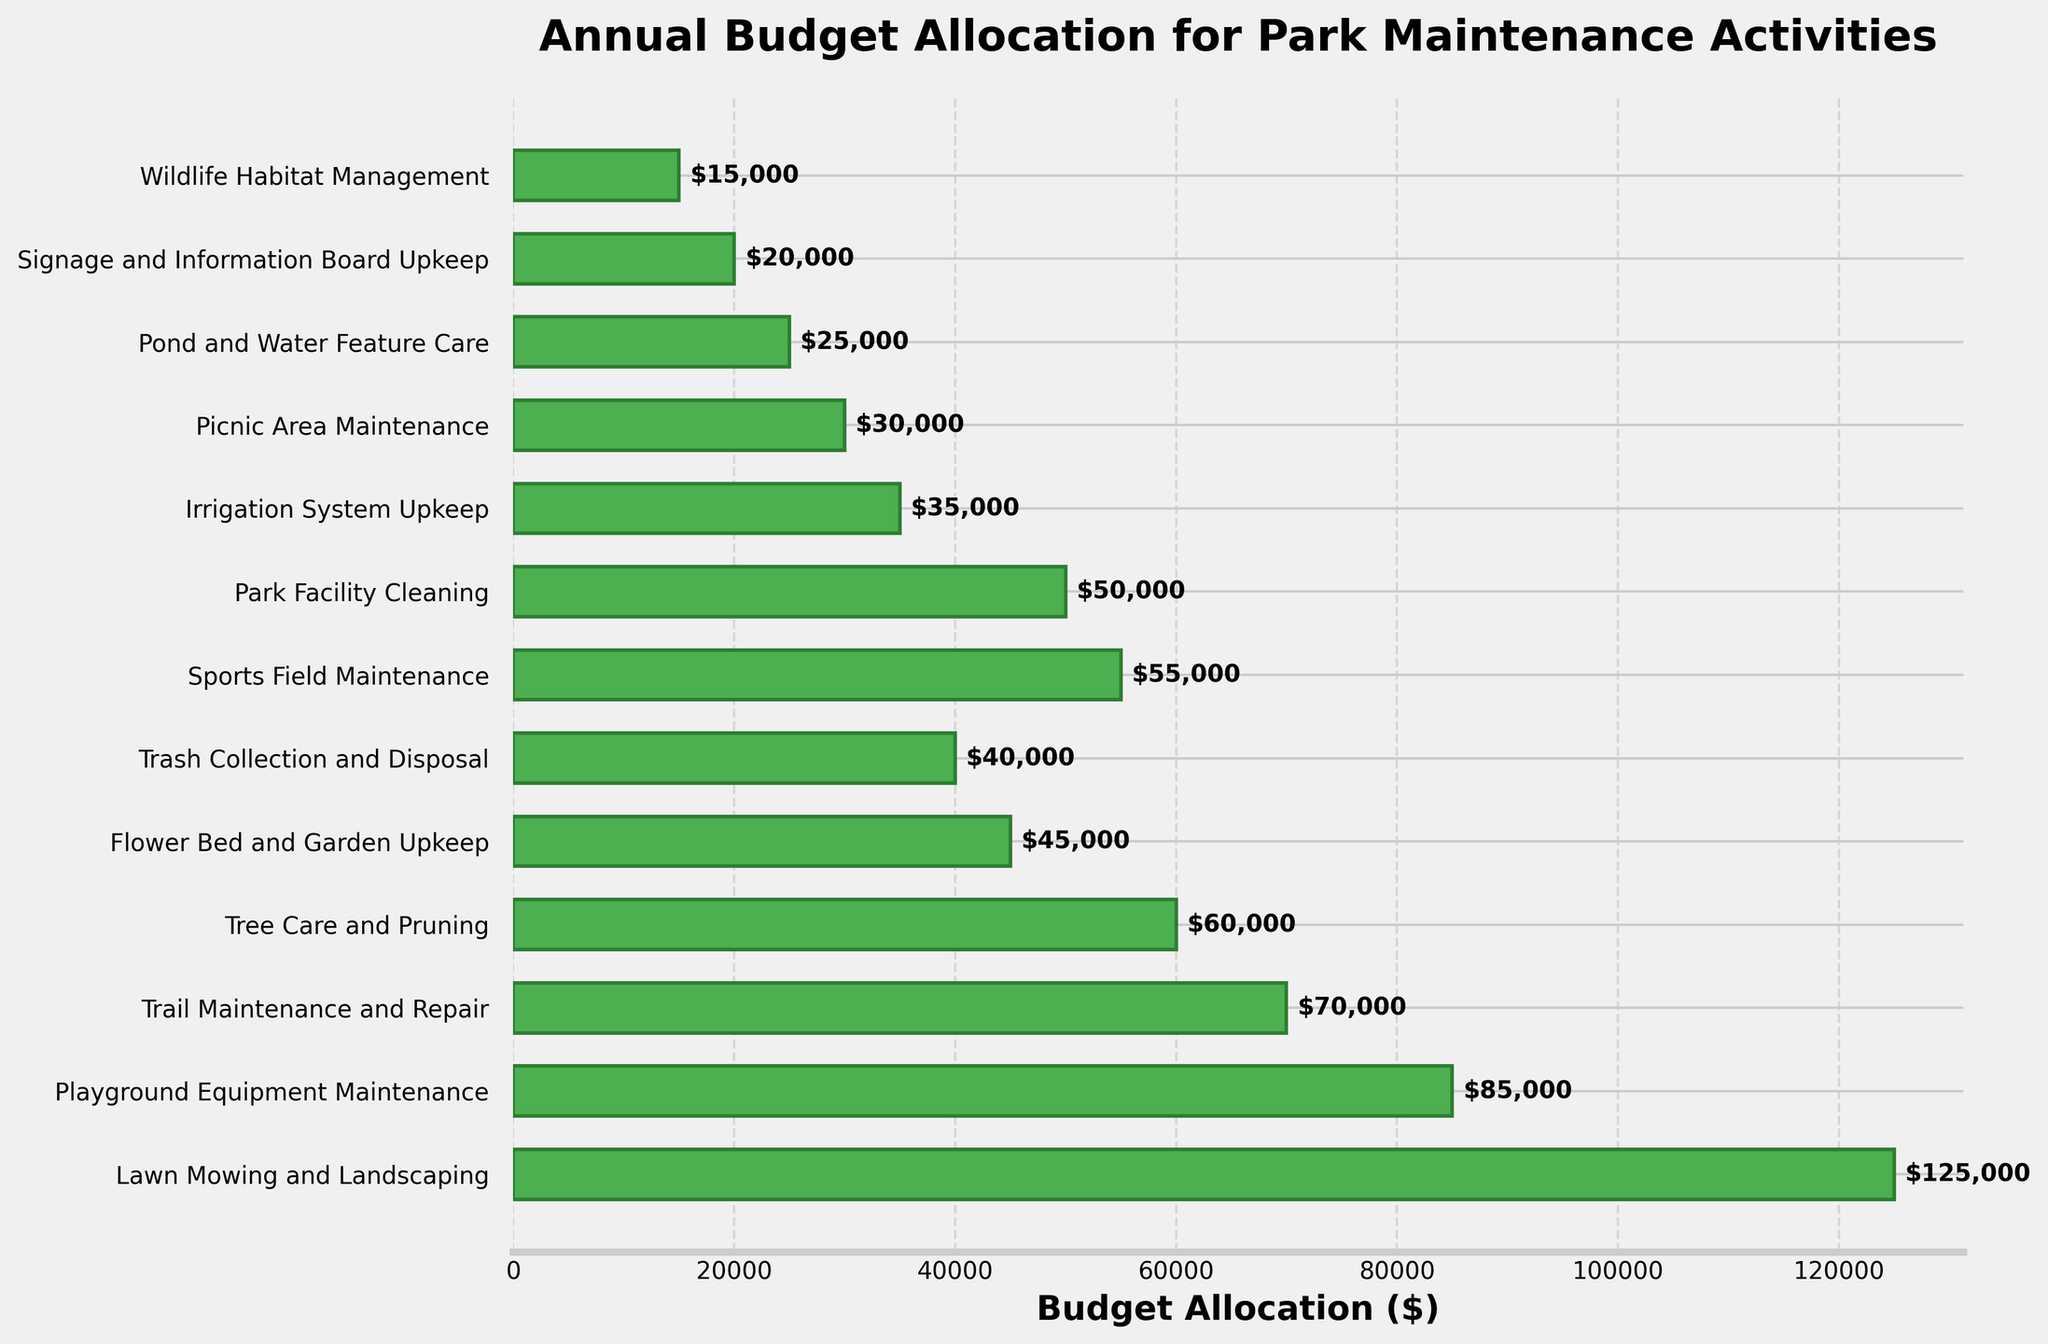What activity receives the highest budget allocation? The bar chart indicates that "Lawn Mowing and Landscaping" has the longest bar, showing it received the highest budget allocation.
Answer: Lawn Mowing and Landscaping Which activities receive a budget allocation of less than $50,000? The activities with budget allocations below $50,000 have shorter bars and include Flower Bed and Garden Upkeep, Trash Collection and Disposal, Park Facility Cleaning, Irrigation System Upkeep, Picnic Area Maintenance, Pond and Water Feature Care, Signage and Information Board Upkeep, and Wildlife Habitat Management.
Answer: Flower Bed and Garden Upkeep, Trash Collection and Disposal, Park Facility Cleaning, Irrigation System Upkeep, Picnic Area Maintenance, Pond and Water Feature Care, Signage and Information Board Upkeep, Wildlife Habitat Management What is the total budget allocation for Trail Maintenance and Repair, Tree Care and Pruning, and Sports Field Maintenance combined? The combined budget allocation is calculated by summing the individual allocations: $70,000 (Trail Maintenance and Repair) + $60,000 (Tree Care and Pruning) + $55,000 (Sports Field Maintenance) = $185,000.
Answer: $185,000 Which activity has a budget allocation $5,000 higher than Irrigation System Upkeep? By observing the chart, we see that Park Facility Cleaning has a budget allocation of $50,000, which is $5,000 higher than the $35,000 allocation for Irrigation System Upkeep.
Answer: Park Facility Cleaning Compare the budget allocation for Playground Equipment Maintenance to Tree Care and Pruning. Which one is higher and by how much? Playground Equipment Maintenance has a budget allocation of $85,000, whereas Tree Care and Pruning has $60,000. The difference is $85,000 - $60,000 = $25,000.
Answer: Playground Equipment Maintenance by $25,000 How does the budget allocation for Trash Collection and Disposal compare to Picnic Area Maintenance? The budget allocation for Trash Collection and Disposal is $40,000, which is $10,000 higher compared to Picnic Area Maintenance's $30,000 allocation.
Answer: $10,000 higher What percentage of the total budget does Lawn Mowing and Landscaping receive? First, calculate the total budget by summing all allocations: $125,000 + $85,000 + $70,000 + $60,000 + $45,000 + $40,000 + $55,000 + $50,000 + $35,000 + $30,000 + $25,000 + $20,000 + $15,000 = $655,000. Then, find the percentage for Lawn Mowing and Landscaping: ($125,000 / $655,000) * 100 ≈ 19.08%.
Answer: 19.08% Which activity has the smallest budget allocation, and how much is it? The shortest bar in the chart corresponds to "Wildlife Habitat Management," which has the smallest budget allocation of $15,000.
Answer: Wildlife Habitat Management, $15,000 If we redistribute $10,000 from Lawn Mowing and Landscaping to Wildlife Habitat Management, what are the new allocations? Original allocations: $125,000 (Lawn Mowing and Landscaping) and $15,000 (Wildlife Habitat Management). New allocations: Lawn Mowing and Landscaping becomes $125,000 - $10,000 = $115,000, and Wildlife Habitat Management becomes $15,000 + $10,000 = $25,000.
Answer: $115,000 for Lawn Mowing and Landscaping, $25,000 for Wildlife Habitat Management 